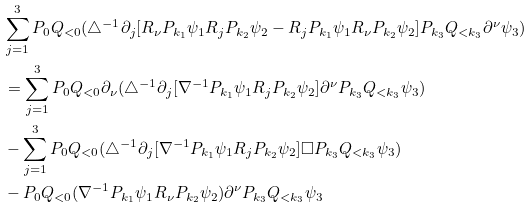<formula> <loc_0><loc_0><loc_500><loc_500>& \sum _ { j = 1 } ^ { 3 } P _ { 0 } Q _ { < 0 } ( \triangle ^ { - 1 } \partial _ { j } [ R _ { \nu } P _ { k _ { 1 } } \psi _ { 1 } R _ { j } P _ { k _ { 2 } } \psi _ { 2 } - R _ { j } P _ { k _ { 1 } } \psi _ { 1 } R _ { \nu } P _ { k _ { 2 } } \psi _ { 2 } ] P _ { k _ { 3 } } Q _ { < k _ { 3 } } \partial ^ { \nu } \psi _ { 3 } ) \\ & = \sum _ { j = 1 } ^ { 3 } P _ { 0 } Q _ { < 0 } \partial _ { \nu } ( \triangle ^ { - 1 } \partial _ { j } [ \nabla ^ { - 1 } P _ { k _ { 1 } } \psi _ { 1 } R _ { j } P _ { k _ { 2 } } \psi _ { 2 } ] \partial ^ { \nu } P _ { k _ { 3 } } Q _ { < k _ { 3 } } \psi _ { 3 } ) \\ & - \sum _ { j = 1 } ^ { 3 } P _ { 0 } Q _ { < 0 } ( \triangle ^ { - 1 } \partial _ { j } [ \nabla ^ { - 1 } P _ { k _ { 1 } } \psi _ { 1 } R _ { j } P _ { k _ { 2 } } \psi _ { 2 } ] \Box P _ { k _ { 3 } } Q _ { < k _ { 3 } } \psi _ { 3 } ) \\ & - P _ { 0 } Q _ { < 0 } ( \nabla ^ { - 1 } P _ { k _ { 1 } } \psi _ { 1 } R _ { \nu } P _ { k _ { 2 } } \psi _ { 2 } ) \partial ^ { \nu } P _ { k _ { 3 } } Q _ { < k _ { 3 } } \psi _ { 3 } \\</formula> 